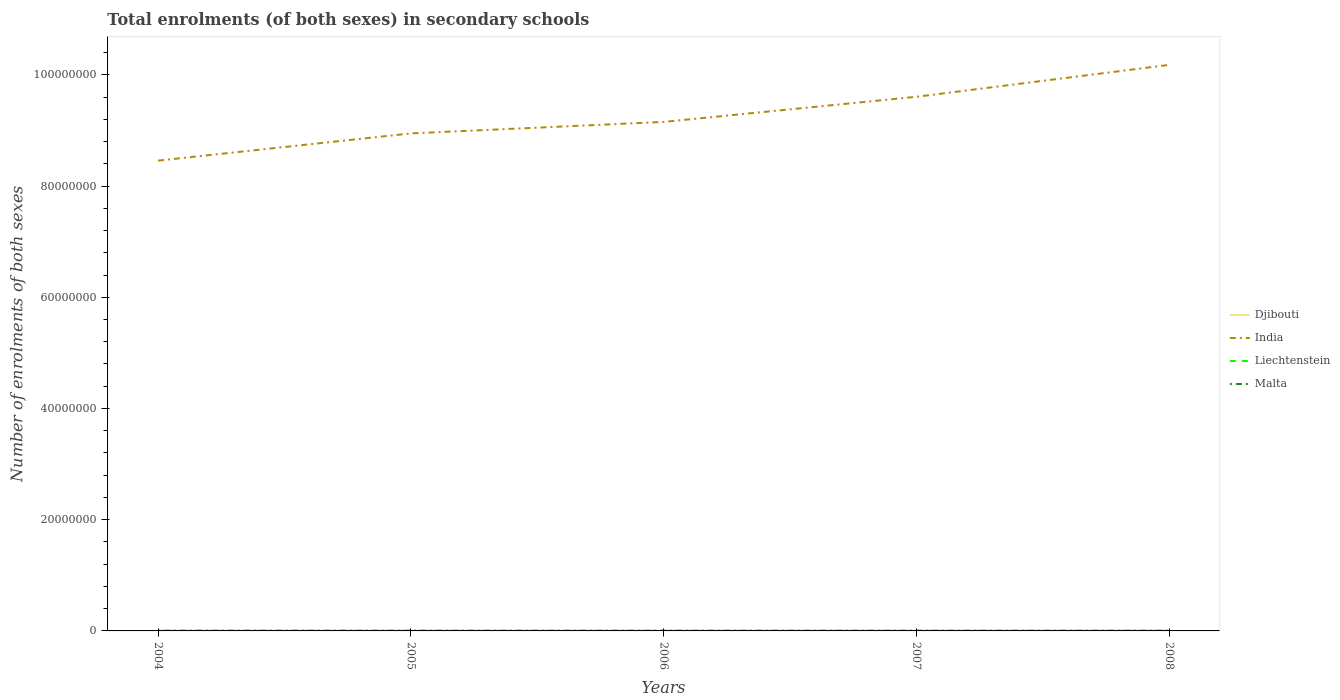How many different coloured lines are there?
Your answer should be compact. 4. Across all years, what is the maximum number of enrolments in secondary schools in Djibouti?
Provide a succinct answer. 2.65e+04. What is the total number of enrolments in secondary schools in Malta in the graph?
Your answer should be compact. 1224. What is the difference between the highest and the second highest number of enrolments in secondary schools in India?
Give a very brief answer. 1.72e+07. What is the difference between the highest and the lowest number of enrolments in secondary schools in Malta?
Ensure brevity in your answer.  2. How many lines are there?
Make the answer very short. 4. Are the values on the major ticks of Y-axis written in scientific E-notation?
Make the answer very short. No. Does the graph contain any zero values?
Your response must be concise. No. What is the title of the graph?
Provide a succinct answer. Total enrolments (of both sexes) in secondary schools. What is the label or title of the Y-axis?
Make the answer very short. Number of enrolments of both sexes. What is the Number of enrolments of both sexes in Djibouti in 2004?
Keep it short and to the point. 2.65e+04. What is the Number of enrolments of both sexes of India in 2004?
Offer a terse response. 8.46e+07. What is the Number of enrolments of both sexes of Liechtenstein in 2004?
Offer a very short reply. 3273. What is the Number of enrolments of both sexes in Malta in 2004?
Your answer should be very brief. 4.14e+04. What is the Number of enrolments of both sexes of Djibouti in 2005?
Ensure brevity in your answer.  3.01e+04. What is the Number of enrolments of both sexes in India in 2005?
Keep it short and to the point. 8.95e+07. What is the Number of enrolments of both sexes of Liechtenstein in 2005?
Offer a terse response. 3142. What is the Number of enrolments of both sexes of Malta in 2005?
Your response must be concise. 4.01e+04. What is the Number of enrolments of both sexes of Djibouti in 2006?
Keep it short and to the point. 3.03e+04. What is the Number of enrolments of both sexes of India in 2006?
Your answer should be very brief. 9.15e+07. What is the Number of enrolments of both sexes in Liechtenstein in 2006?
Offer a very short reply. 3190. What is the Number of enrolments of both sexes in Malta in 2006?
Your answer should be compact. 3.83e+04. What is the Number of enrolments of both sexes of Djibouti in 2007?
Offer a very short reply. 3.50e+04. What is the Number of enrolments of both sexes of India in 2007?
Make the answer very short. 9.60e+07. What is the Number of enrolments of both sexes of Liechtenstein in 2007?
Your response must be concise. 3169. What is the Number of enrolments of both sexes of Malta in 2007?
Offer a terse response. 3.85e+04. What is the Number of enrolments of both sexes of Djibouti in 2008?
Offer a terse response. 4.12e+04. What is the Number of enrolments of both sexes in India in 2008?
Make the answer very short. 1.02e+08. What is the Number of enrolments of both sexes of Liechtenstein in 2008?
Your answer should be very brief. 3213. What is the Number of enrolments of both sexes of Malta in 2008?
Give a very brief answer. 3.78e+04. Across all years, what is the maximum Number of enrolments of both sexes of Djibouti?
Make the answer very short. 4.12e+04. Across all years, what is the maximum Number of enrolments of both sexes of India?
Provide a succinct answer. 1.02e+08. Across all years, what is the maximum Number of enrolments of both sexes in Liechtenstein?
Keep it short and to the point. 3273. Across all years, what is the maximum Number of enrolments of both sexes in Malta?
Your response must be concise. 4.14e+04. Across all years, what is the minimum Number of enrolments of both sexes in Djibouti?
Offer a very short reply. 2.65e+04. Across all years, what is the minimum Number of enrolments of both sexes in India?
Keep it short and to the point. 8.46e+07. Across all years, what is the minimum Number of enrolments of both sexes in Liechtenstein?
Make the answer very short. 3142. Across all years, what is the minimum Number of enrolments of both sexes of Malta?
Ensure brevity in your answer.  3.78e+04. What is the total Number of enrolments of both sexes of Djibouti in the graph?
Provide a short and direct response. 1.63e+05. What is the total Number of enrolments of both sexes in India in the graph?
Provide a succinct answer. 4.63e+08. What is the total Number of enrolments of both sexes in Liechtenstein in the graph?
Make the answer very short. 1.60e+04. What is the total Number of enrolments of both sexes of Malta in the graph?
Your answer should be compact. 1.96e+05. What is the difference between the Number of enrolments of both sexes of Djibouti in 2004 and that in 2005?
Provide a short and direct response. -3593. What is the difference between the Number of enrolments of both sexes of India in 2004 and that in 2005?
Provide a short and direct response. -4.89e+06. What is the difference between the Number of enrolments of both sexes of Liechtenstein in 2004 and that in 2005?
Provide a succinct answer. 131. What is the difference between the Number of enrolments of both sexes of Malta in 2004 and that in 2005?
Your answer should be compact. 1224. What is the difference between the Number of enrolments of both sexes of Djibouti in 2004 and that in 2006?
Ensure brevity in your answer.  -3716. What is the difference between the Number of enrolments of both sexes of India in 2004 and that in 2006?
Make the answer very short. -6.96e+06. What is the difference between the Number of enrolments of both sexes in Malta in 2004 and that in 2006?
Ensure brevity in your answer.  3018. What is the difference between the Number of enrolments of both sexes in Djibouti in 2004 and that in 2007?
Offer a terse response. -8423. What is the difference between the Number of enrolments of both sexes in India in 2004 and that in 2007?
Offer a terse response. -1.15e+07. What is the difference between the Number of enrolments of both sexes of Liechtenstein in 2004 and that in 2007?
Offer a very short reply. 104. What is the difference between the Number of enrolments of both sexes in Malta in 2004 and that in 2007?
Your answer should be compact. 2854. What is the difference between the Number of enrolments of both sexes of Djibouti in 2004 and that in 2008?
Your answer should be compact. -1.46e+04. What is the difference between the Number of enrolments of both sexes of India in 2004 and that in 2008?
Give a very brief answer. -1.72e+07. What is the difference between the Number of enrolments of both sexes in Malta in 2004 and that in 2008?
Offer a terse response. 3579. What is the difference between the Number of enrolments of both sexes in Djibouti in 2005 and that in 2006?
Your response must be concise. -123. What is the difference between the Number of enrolments of both sexes in India in 2005 and that in 2006?
Ensure brevity in your answer.  -2.07e+06. What is the difference between the Number of enrolments of both sexes of Liechtenstein in 2005 and that in 2006?
Provide a succinct answer. -48. What is the difference between the Number of enrolments of both sexes in Malta in 2005 and that in 2006?
Keep it short and to the point. 1794. What is the difference between the Number of enrolments of both sexes in Djibouti in 2005 and that in 2007?
Your answer should be very brief. -4830. What is the difference between the Number of enrolments of both sexes of India in 2005 and that in 2007?
Offer a very short reply. -6.59e+06. What is the difference between the Number of enrolments of both sexes in Malta in 2005 and that in 2007?
Offer a very short reply. 1630. What is the difference between the Number of enrolments of both sexes in Djibouti in 2005 and that in 2008?
Keep it short and to the point. -1.10e+04. What is the difference between the Number of enrolments of both sexes of India in 2005 and that in 2008?
Provide a short and direct response. -1.23e+07. What is the difference between the Number of enrolments of both sexes in Liechtenstein in 2005 and that in 2008?
Provide a succinct answer. -71. What is the difference between the Number of enrolments of both sexes in Malta in 2005 and that in 2008?
Make the answer very short. 2355. What is the difference between the Number of enrolments of both sexes in Djibouti in 2006 and that in 2007?
Your response must be concise. -4707. What is the difference between the Number of enrolments of both sexes in India in 2006 and that in 2007?
Your answer should be compact. -4.52e+06. What is the difference between the Number of enrolments of both sexes of Malta in 2006 and that in 2007?
Your answer should be compact. -164. What is the difference between the Number of enrolments of both sexes of Djibouti in 2006 and that in 2008?
Offer a terse response. -1.09e+04. What is the difference between the Number of enrolments of both sexes of India in 2006 and that in 2008?
Give a very brief answer. -1.03e+07. What is the difference between the Number of enrolments of both sexes in Malta in 2006 and that in 2008?
Make the answer very short. 561. What is the difference between the Number of enrolments of both sexes of Djibouti in 2007 and that in 2008?
Keep it short and to the point. -6187. What is the difference between the Number of enrolments of both sexes of India in 2007 and that in 2008?
Ensure brevity in your answer.  -5.73e+06. What is the difference between the Number of enrolments of both sexes in Liechtenstein in 2007 and that in 2008?
Provide a short and direct response. -44. What is the difference between the Number of enrolments of both sexes of Malta in 2007 and that in 2008?
Your answer should be very brief. 725. What is the difference between the Number of enrolments of both sexes in Djibouti in 2004 and the Number of enrolments of both sexes in India in 2005?
Ensure brevity in your answer.  -8.94e+07. What is the difference between the Number of enrolments of both sexes in Djibouti in 2004 and the Number of enrolments of both sexes in Liechtenstein in 2005?
Give a very brief answer. 2.34e+04. What is the difference between the Number of enrolments of both sexes in Djibouti in 2004 and the Number of enrolments of both sexes in Malta in 2005?
Your response must be concise. -1.36e+04. What is the difference between the Number of enrolments of both sexes in India in 2004 and the Number of enrolments of both sexes in Liechtenstein in 2005?
Ensure brevity in your answer.  8.46e+07. What is the difference between the Number of enrolments of both sexes in India in 2004 and the Number of enrolments of both sexes in Malta in 2005?
Keep it short and to the point. 8.45e+07. What is the difference between the Number of enrolments of both sexes in Liechtenstein in 2004 and the Number of enrolments of both sexes in Malta in 2005?
Give a very brief answer. -3.69e+04. What is the difference between the Number of enrolments of both sexes of Djibouti in 2004 and the Number of enrolments of both sexes of India in 2006?
Provide a short and direct response. -9.15e+07. What is the difference between the Number of enrolments of both sexes in Djibouti in 2004 and the Number of enrolments of both sexes in Liechtenstein in 2006?
Give a very brief answer. 2.34e+04. What is the difference between the Number of enrolments of both sexes in Djibouti in 2004 and the Number of enrolments of both sexes in Malta in 2006?
Make the answer very short. -1.18e+04. What is the difference between the Number of enrolments of both sexes of India in 2004 and the Number of enrolments of both sexes of Liechtenstein in 2006?
Keep it short and to the point. 8.46e+07. What is the difference between the Number of enrolments of both sexes of India in 2004 and the Number of enrolments of both sexes of Malta in 2006?
Offer a terse response. 8.45e+07. What is the difference between the Number of enrolments of both sexes in Liechtenstein in 2004 and the Number of enrolments of both sexes in Malta in 2006?
Ensure brevity in your answer.  -3.51e+04. What is the difference between the Number of enrolments of both sexes in Djibouti in 2004 and the Number of enrolments of both sexes in India in 2007?
Keep it short and to the point. -9.60e+07. What is the difference between the Number of enrolments of both sexes in Djibouti in 2004 and the Number of enrolments of both sexes in Liechtenstein in 2007?
Provide a succinct answer. 2.34e+04. What is the difference between the Number of enrolments of both sexes of Djibouti in 2004 and the Number of enrolments of both sexes of Malta in 2007?
Offer a terse response. -1.20e+04. What is the difference between the Number of enrolments of both sexes in India in 2004 and the Number of enrolments of both sexes in Liechtenstein in 2007?
Provide a short and direct response. 8.46e+07. What is the difference between the Number of enrolments of both sexes of India in 2004 and the Number of enrolments of both sexes of Malta in 2007?
Offer a very short reply. 8.45e+07. What is the difference between the Number of enrolments of both sexes of Liechtenstein in 2004 and the Number of enrolments of both sexes of Malta in 2007?
Your answer should be compact. -3.52e+04. What is the difference between the Number of enrolments of both sexes of Djibouti in 2004 and the Number of enrolments of both sexes of India in 2008?
Make the answer very short. -1.02e+08. What is the difference between the Number of enrolments of both sexes of Djibouti in 2004 and the Number of enrolments of both sexes of Liechtenstein in 2008?
Provide a succinct answer. 2.33e+04. What is the difference between the Number of enrolments of both sexes in Djibouti in 2004 and the Number of enrolments of both sexes in Malta in 2008?
Your answer should be very brief. -1.12e+04. What is the difference between the Number of enrolments of both sexes of India in 2004 and the Number of enrolments of both sexes of Liechtenstein in 2008?
Make the answer very short. 8.46e+07. What is the difference between the Number of enrolments of both sexes of India in 2004 and the Number of enrolments of both sexes of Malta in 2008?
Offer a very short reply. 8.45e+07. What is the difference between the Number of enrolments of both sexes of Liechtenstein in 2004 and the Number of enrolments of both sexes of Malta in 2008?
Offer a terse response. -3.45e+04. What is the difference between the Number of enrolments of both sexes in Djibouti in 2005 and the Number of enrolments of both sexes in India in 2006?
Give a very brief answer. -9.15e+07. What is the difference between the Number of enrolments of both sexes of Djibouti in 2005 and the Number of enrolments of both sexes of Liechtenstein in 2006?
Ensure brevity in your answer.  2.70e+04. What is the difference between the Number of enrolments of both sexes of Djibouti in 2005 and the Number of enrolments of both sexes of Malta in 2006?
Your response must be concise. -8193. What is the difference between the Number of enrolments of both sexes of India in 2005 and the Number of enrolments of both sexes of Liechtenstein in 2006?
Provide a succinct answer. 8.95e+07. What is the difference between the Number of enrolments of both sexes in India in 2005 and the Number of enrolments of both sexes in Malta in 2006?
Provide a short and direct response. 8.94e+07. What is the difference between the Number of enrolments of both sexes in Liechtenstein in 2005 and the Number of enrolments of both sexes in Malta in 2006?
Keep it short and to the point. -3.52e+04. What is the difference between the Number of enrolments of both sexes in Djibouti in 2005 and the Number of enrolments of both sexes in India in 2007?
Ensure brevity in your answer.  -9.60e+07. What is the difference between the Number of enrolments of both sexes in Djibouti in 2005 and the Number of enrolments of both sexes in Liechtenstein in 2007?
Make the answer very short. 2.70e+04. What is the difference between the Number of enrolments of both sexes of Djibouti in 2005 and the Number of enrolments of both sexes of Malta in 2007?
Your response must be concise. -8357. What is the difference between the Number of enrolments of both sexes in India in 2005 and the Number of enrolments of both sexes in Liechtenstein in 2007?
Give a very brief answer. 8.95e+07. What is the difference between the Number of enrolments of both sexes of India in 2005 and the Number of enrolments of both sexes of Malta in 2007?
Provide a short and direct response. 8.94e+07. What is the difference between the Number of enrolments of both sexes in Liechtenstein in 2005 and the Number of enrolments of both sexes in Malta in 2007?
Provide a short and direct response. -3.54e+04. What is the difference between the Number of enrolments of both sexes in Djibouti in 2005 and the Number of enrolments of both sexes in India in 2008?
Provide a succinct answer. -1.02e+08. What is the difference between the Number of enrolments of both sexes of Djibouti in 2005 and the Number of enrolments of both sexes of Liechtenstein in 2008?
Offer a very short reply. 2.69e+04. What is the difference between the Number of enrolments of both sexes in Djibouti in 2005 and the Number of enrolments of both sexes in Malta in 2008?
Provide a short and direct response. -7632. What is the difference between the Number of enrolments of both sexes in India in 2005 and the Number of enrolments of both sexes in Liechtenstein in 2008?
Your response must be concise. 8.95e+07. What is the difference between the Number of enrolments of both sexes of India in 2005 and the Number of enrolments of both sexes of Malta in 2008?
Offer a terse response. 8.94e+07. What is the difference between the Number of enrolments of both sexes of Liechtenstein in 2005 and the Number of enrolments of both sexes of Malta in 2008?
Your response must be concise. -3.46e+04. What is the difference between the Number of enrolments of both sexes in Djibouti in 2006 and the Number of enrolments of both sexes in India in 2007?
Give a very brief answer. -9.60e+07. What is the difference between the Number of enrolments of both sexes of Djibouti in 2006 and the Number of enrolments of both sexes of Liechtenstein in 2007?
Your answer should be compact. 2.71e+04. What is the difference between the Number of enrolments of both sexes in Djibouti in 2006 and the Number of enrolments of both sexes in Malta in 2007?
Provide a short and direct response. -8234. What is the difference between the Number of enrolments of both sexes in India in 2006 and the Number of enrolments of both sexes in Liechtenstein in 2007?
Provide a succinct answer. 9.15e+07. What is the difference between the Number of enrolments of both sexes of India in 2006 and the Number of enrolments of both sexes of Malta in 2007?
Ensure brevity in your answer.  9.15e+07. What is the difference between the Number of enrolments of both sexes in Liechtenstein in 2006 and the Number of enrolments of both sexes in Malta in 2007?
Ensure brevity in your answer.  -3.53e+04. What is the difference between the Number of enrolments of both sexes of Djibouti in 2006 and the Number of enrolments of both sexes of India in 2008?
Make the answer very short. -1.02e+08. What is the difference between the Number of enrolments of both sexes of Djibouti in 2006 and the Number of enrolments of both sexes of Liechtenstein in 2008?
Make the answer very short. 2.71e+04. What is the difference between the Number of enrolments of both sexes of Djibouti in 2006 and the Number of enrolments of both sexes of Malta in 2008?
Keep it short and to the point. -7509. What is the difference between the Number of enrolments of both sexes in India in 2006 and the Number of enrolments of both sexes in Liechtenstein in 2008?
Offer a very short reply. 9.15e+07. What is the difference between the Number of enrolments of both sexes of India in 2006 and the Number of enrolments of both sexes of Malta in 2008?
Keep it short and to the point. 9.15e+07. What is the difference between the Number of enrolments of both sexes in Liechtenstein in 2006 and the Number of enrolments of both sexes in Malta in 2008?
Offer a very short reply. -3.46e+04. What is the difference between the Number of enrolments of both sexes in Djibouti in 2007 and the Number of enrolments of both sexes in India in 2008?
Provide a succinct answer. -1.02e+08. What is the difference between the Number of enrolments of both sexes in Djibouti in 2007 and the Number of enrolments of both sexes in Liechtenstein in 2008?
Offer a terse response. 3.18e+04. What is the difference between the Number of enrolments of both sexes in Djibouti in 2007 and the Number of enrolments of both sexes in Malta in 2008?
Offer a terse response. -2802. What is the difference between the Number of enrolments of both sexes of India in 2007 and the Number of enrolments of both sexes of Liechtenstein in 2008?
Provide a succinct answer. 9.60e+07. What is the difference between the Number of enrolments of both sexes in India in 2007 and the Number of enrolments of both sexes in Malta in 2008?
Provide a short and direct response. 9.60e+07. What is the difference between the Number of enrolments of both sexes of Liechtenstein in 2007 and the Number of enrolments of both sexes of Malta in 2008?
Offer a very short reply. -3.46e+04. What is the average Number of enrolments of both sexes in Djibouti per year?
Offer a very short reply. 3.26e+04. What is the average Number of enrolments of both sexes in India per year?
Your response must be concise. 9.27e+07. What is the average Number of enrolments of both sexes in Liechtenstein per year?
Keep it short and to the point. 3197.4. What is the average Number of enrolments of both sexes of Malta per year?
Keep it short and to the point. 3.92e+04. In the year 2004, what is the difference between the Number of enrolments of both sexes of Djibouti and Number of enrolments of both sexes of India?
Provide a succinct answer. -8.45e+07. In the year 2004, what is the difference between the Number of enrolments of both sexes of Djibouti and Number of enrolments of both sexes of Liechtenstein?
Your answer should be very brief. 2.33e+04. In the year 2004, what is the difference between the Number of enrolments of both sexes of Djibouti and Number of enrolments of both sexes of Malta?
Offer a terse response. -1.48e+04. In the year 2004, what is the difference between the Number of enrolments of both sexes in India and Number of enrolments of both sexes in Liechtenstein?
Your answer should be very brief. 8.46e+07. In the year 2004, what is the difference between the Number of enrolments of both sexes of India and Number of enrolments of both sexes of Malta?
Your answer should be compact. 8.45e+07. In the year 2004, what is the difference between the Number of enrolments of both sexes in Liechtenstein and Number of enrolments of both sexes in Malta?
Give a very brief answer. -3.81e+04. In the year 2005, what is the difference between the Number of enrolments of both sexes in Djibouti and Number of enrolments of both sexes in India?
Ensure brevity in your answer.  -8.94e+07. In the year 2005, what is the difference between the Number of enrolments of both sexes of Djibouti and Number of enrolments of both sexes of Liechtenstein?
Your response must be concise. 2.70e+04. In the year 2005, what is the difference between the Number of enrolments of both sexes in Djibouti and Number of enrolments of both sexes in Malta?
Give a very brief answer. -9987. In the year 2005, what is the difference between the Number of enrolments of both sexes in India and Number of enrolments of both sexes in Liechtenstein?
Keep it short and to the point. 8.95e+07. In the year 2005, what is the difference between the Number of enrolments of both sexes of India and Number of enrolments of both sexes of Malta?
Ensure brevity in your answer.  8.94e+07. In the year 2005, what is the difference between the Number of enrolments of both sexes in Liechtenstein and Number of enrolments of both sexes in Malta?
Your answer should be very brief. -3.70e+04. In the year 2006, what is the difference between the Number of enrolments of both sexes in Djibouti and Number of enrolments of both sexes in India?
Provide a short and direct response. -9.15e+07. In the year 2006, what is the difference between the Number of enrolments of both sexes in Djibouti and Number of enrolments of both sexes in Liechtenstein?
Give a very brief answer. 2.71e+04. In the year 2006, what is the difference between the Number of enrolments of both sexes of Djibouti and Number of enrolments of both sexes of Malta?
Your response must be concise. -8070. In the year 2006, what is the difference between the Number of enrolments of both sexes of India and Number of enrolments of both sexes of Liechtenstein?
Provide a succinct answer. 9.15e+07. In the year 2006, what is the difference between the Number of enrolments of both sexes in India and Number of enrolments of both sexes in Malta?
Your answer should be very brief. 9.15e+07. In the year 2006, what is the difference between the Number of enrolments of both sexes of Liechtenstein and Number of enrolments of both sexes of Malta?
Your response must be concise. -3.51e+04. In the year 2007, what is the difference between the Number of enrolments of both sexes in Djibouti and Number of enrolments of both sexes in India?
Make the answer very short. -9.60e+07. In the year 2007, what is the difference between the Number of enrolments of both sexes in Djibouti and Number of enrolments of both sexes in Liechtenstein?
Offer a very short reply. 3.18e+04. In the year 2007, what is the difference between the Number of enrolments of both sexes in Djibouti and Number of enrolments of both sexes in Malta?
Your response must be concise. -3527. In the year 2007, what is the difference between the Number of enrolments of both sexes of India and Number of enrolments of both sexes of Liechtenstein?
Ensure brevity in your answer.  9.60e+07. In the year 2007, what is the difference between the Number of enrolments of both sexes of India and Number of enrolments of both sexes of Malta?
Provide a short and direct response. 9.60e+07. In the year 2007, what is the difference between the Number of enrolments of both sexes of Liechtenstein and Number of enrolments of both sexes of Malta?
Keep it short and to the point. -3.53e+04. In the year 2008, what is the difference between the Number of enrolments of both sexes in Djibouti and Number of enrolments of both sexes in India?
Make the answer very short. -1.02e+08. In the year 2008, what is the difference between the Number of enrolments of both sexes of Djibouti and Number of enrolments of both sexes of Liechtenstein?
Your answer should be very brief. 3.79e+04. In the year 2008, what is the difference between the Number of enrolments of both sexes of Djibouti and Number of enrolments of both sexes of Malta?
Ensure brevity in your answer.  3385. In the year 2008, what is the difference between the Number of enrolments of both sexes in India and Number of enrolments of both sexes in Liechtenstein?
Provide a succinct answer. 1.02e+08. In the year 2008, what is the difference between the Number of enrolments of both sexes of India and Number of enrolments of both sexes of Malta?
Give a very brief answer. 1.02e+08. In the year 2008, what is the difference between the Number of enrolments of both sexes in Liechtenstein and Number of enrolments of both sexes in Malta?
Ensure brevity in your answer.  -3.46e+04. What is the ratio of the Number of enrolments of both sexes in Djibouti in 2004 to that in 2005?
Give a very brief answer. 0.88. What is the ratio of the Number of enrolments of both sexes in India in 2004 to that in 2005?
Your answer should be very brief. 0.95. What is the ratio of the Number of enrolments of both sexes of Liechtenstein in 2004 to that in 2005?
Keep it short and to the point. 1.04. What is the ratio of the Number of enrolments of both sexes in Malta in 2004 to that in 2005?
Keep it short and to the point. 1.03. What is the ratio of the Number of enrolments of both sexes of Djibouti in 2004 to that in 2006?
Offer a very short reply. 0.88. What is the ratio of the Number of enrolments of both sexes in India in 2004 to that in 2006?
Give a very brief answer. 0.92. What is the ratio of the Number of enrolments of both sexes of Liechtenstein in 2004 to that in 2006?
Your answer should be very brief. 1.03. What is the ratio of the Number of enrolments of both sexes of Malta in 2004 to that in 2006?
Offer a terse response. 1.08. What is the ratio of the Number of enrolments of both sexes of Djibouti in 2004 to that in 2007?
Your answer should be compact. 0.76. What is the ratio of the Number of enrolments of both sexes in India in 2004 to that in 2007?
Keep it short and to the point. 0.88. What is the ratio of the Number of enrolments of both sexes in Liechtenstein in 2004 to that in 2007?
Make the answer very short. 1.03. What is the ratio of the Number of enrolments of both sexes in Malta in 2004 to that in 2007?
Your answer should be very brief. 1.07. What is the ratio of the Number of enrolments of both sexes of Djibouti in 2004 to that in 2008?
Your answer should be compact. 0.65. What is the ratio of the Number of enrolments of both sexes in India in 2004 to that in 2008?
Keep it short and to the point. 0.83. What is the ratio of the Number of enrolments of both sexes of Liechtenstein in 2004 to that in 2008?
Offer a very short reply. 1.02. What is the ratio of the Number of enrolments of both sexes of Malta in 2004 to that in 2008?
Your answer should be very brief. 1.09. What is the ratio of the Number of enrolments of both sexes in India in 2005 to that in 2006?
Provide a succinct answer. 0.98. What is the ratio of the Number of enrolments of both sexes in Liechtenstein in 2005 to that in 2006?
Your answer should be very brief. 0.98. What is the ratio of the Number of enrolments of both sexes of Malta in 2005 to that in 2006?
Provide a short and direct response. 1.05. What is the ratio of the Number of enrolments of both sexes in Djibouti in 2005 to that in 2007?
Provide a succinct answer. 0.86. What is the ratio of the Number of enrolments of both sexes in India in 2005 to that in 2007?
Make the answer very short. 0.93. What is the ratio of the Number of enrolments of both sexes in Liechtenstein in 2005 to that in 2007?
Offer a terse response. 0.99. What is the ratio of the Number of enrolments of both sexes in Malta in 2005 to that in 2007?
Give a very brief answer. 1.04. What is the ratio of the Number of enrolments of both sexes of Djibouti in 2005 to that in 2008?
Give a very brief answer. 0.73. What is the ratio of the Number of enrolments of both sexes in India in 2005 to that in 2008?
Your response must be concise. 0.88. What is the ratio of the Number of enrolments of both sexes of Liechtenstein in 2005 to that in 2008?
Your answer should be very brief. 0.98. What is the ratio of the Number of enrolments of both sexes in Malta in 2005 to that in 2008?
Your answer should be very brief. 1.06. What is the ratio of the Number of enrolments of both sexes in Djibouti in 2006 to that in 2007?
Ensure brevity in your answer.  0.87. What is the ratio of the Number of enrolments of both sexes of India in 2006 to that in 2007?
Make the answer very short. 0.95. What is the ratio of the Number of enrolments of both sexes of Liechtenstein in 2006 to that in 2007?
Your answer should be compact. 1.01. What is the ratio of the Number of enrolments of both sexes in Djibouti in 2006 to that in 2008?
Offer a very short reply. 0.74. What is the ratio of the Number of enrolments of both sexes of India in 2006 to that in 2008?
Offer a terse response. 0.9. What is the ratio of the Number of enrolments of both sexes in Malta in 2006 to that in 2008?
Give a very brief answer. 1.01. What is the ratio of the Number of enrolments of both sexes in Djibouti in 2007 to that in 2008?
Your answer should be very brief. 0.85. What is the ratio of the Number of enrolments of both sexes of India in 2007 to that in 2008?
Provide a succinct answer. 0.94. What is the ratio of the Number of enrolments of both sexes of Liechtenstein in 2007 to that in 2008?
Make the answer very short. 0.99. What is the ratio of the Number of enrolments of both sexes of Malta in 2007 to that in 2008?
Your answer should be compact. 1.02. What is the difference between the highest and the second highest Number of enrolments of both sexes in Djibouti?
Make the answer very short. 6187. What is the difference between the highest and the second highest Number of enrolments of both sexes of India?
Offer a very short reply. 5.73e+06. What is the difference between the highest and the second highest Number of enrolments of both sexes of Liechtenstein?
Offer a very short reply. 60. What is the difference between the highest and the second highest Number of enrolments of both sexes of Malta?
Keep it short and to the point. 1224. What is the difference between the highest and the lowest Number of enrolments of both sexes of Djibouti?
Offer a very short reply. 1.46e+04. What is the difference between the highest and the lowest Number of enrolments of both sexes in India?
Ensure brevity in your answer.  1.72e+07. What is the difference between the highest and the lowest Number of enrolments of both sexes of Liechtenstein?
Give a very brief answer. 131. What is the difference between the highest and the lowest Number of enrolments of both sexes in Malta?
Offer a terse response. 3579. 